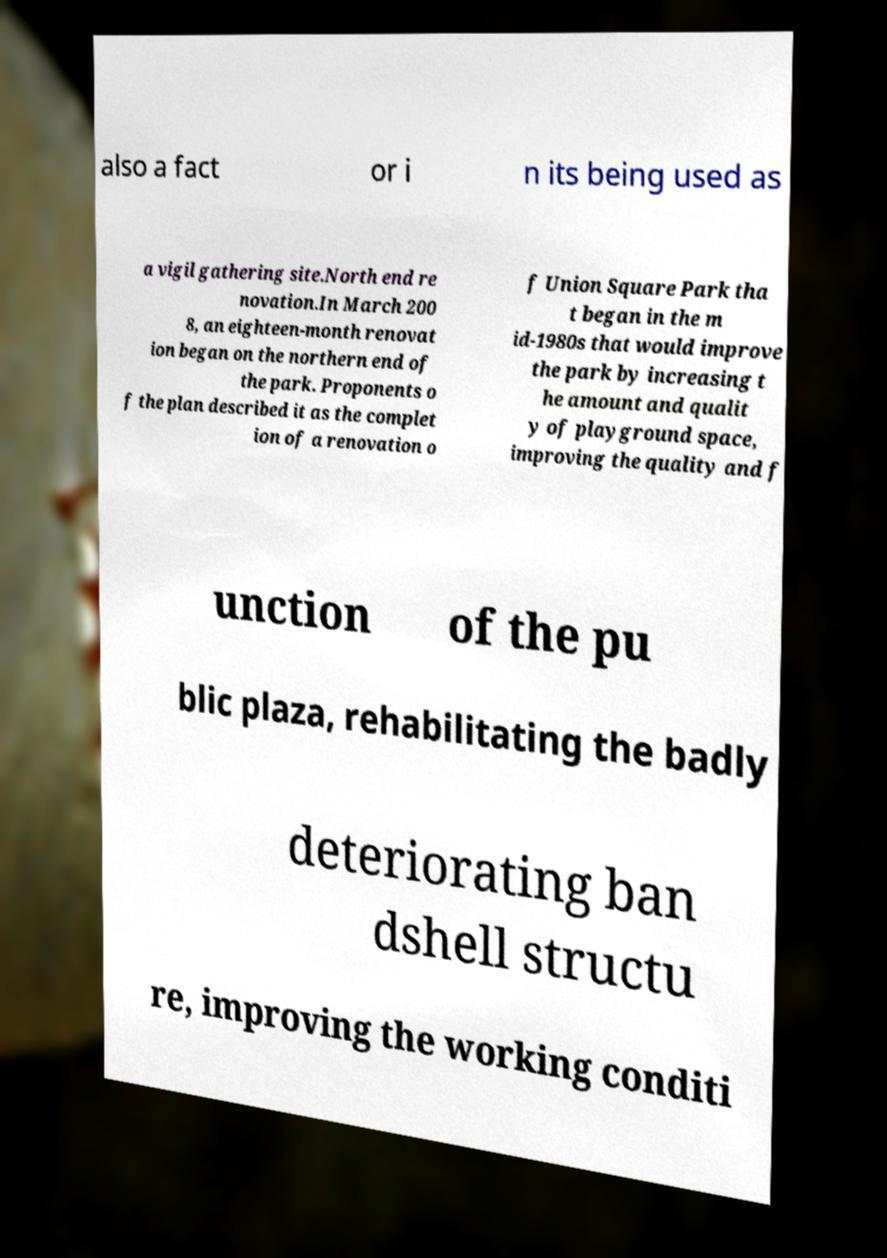For documentation purposes, I need the text within this image transcribed. Could you provide that? also a fact or i n its being used as a vigil gathering site.North end re novation.In March 200 8, an eighteen-month renovat ion began on the northern end of the park. Proponents o f the plan described it as the complet ion of a renovation o f Union Square Park tha t began in the m id-1980s that would improve the park by increasing t he amount and qualit y of playground space, improving the quality and f unction of the pu blic plaza, rehabilitating the badly deteriorating ban dshell structu re, improving the working conditi 